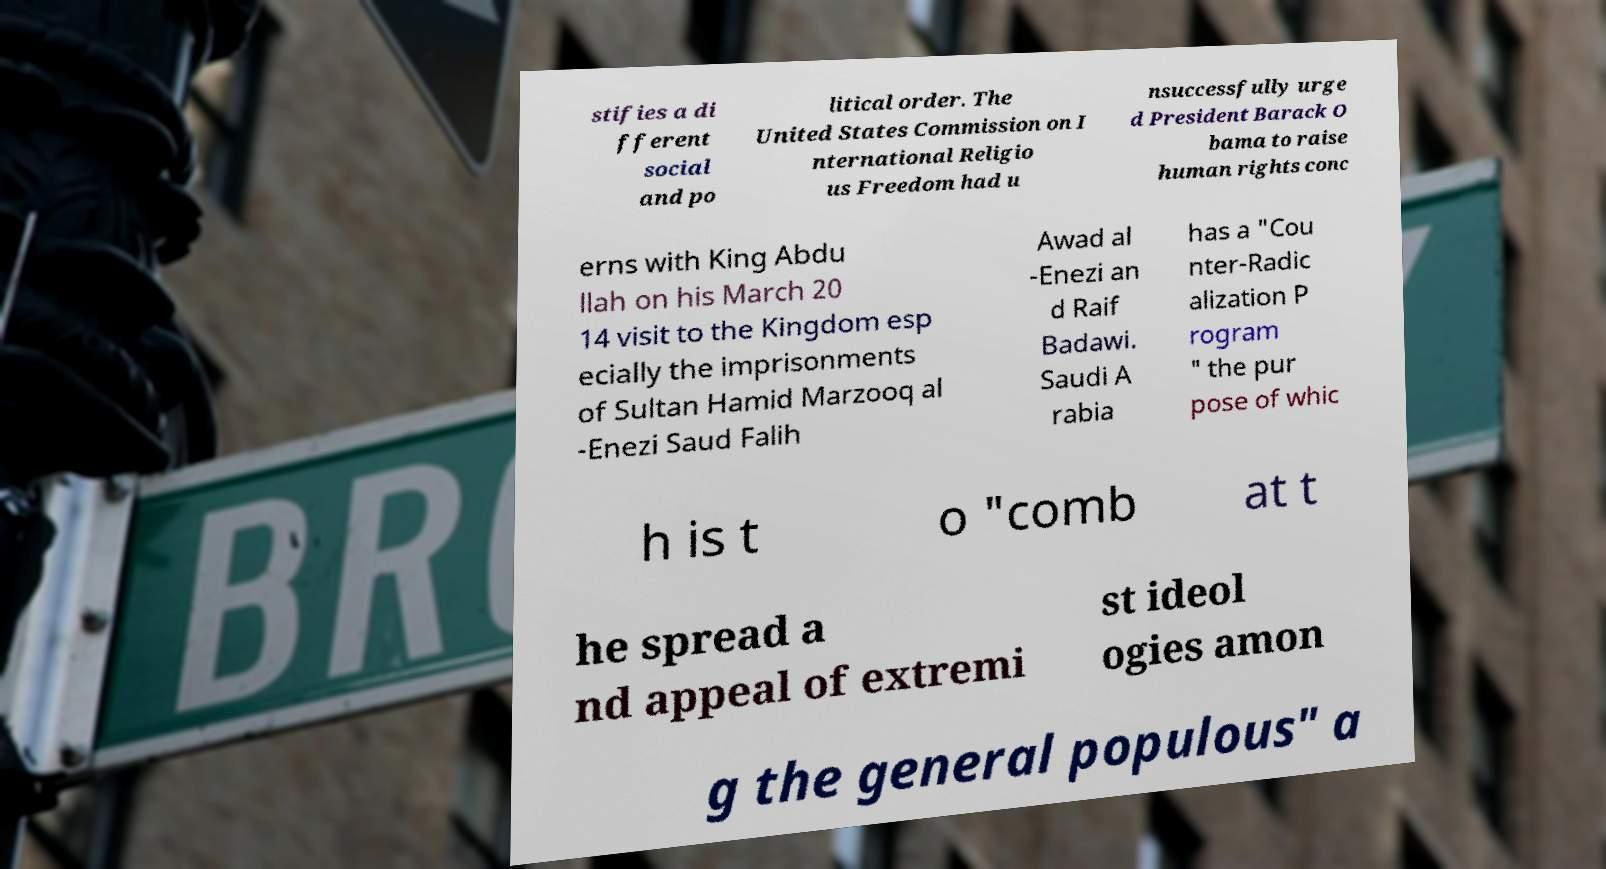For documentation purposes, I need the text within this image transcribed. Could you provide that? stifies a di fferent social and po litical order. The United States Commission on I nternational Religio us Freedom had u nsuccessfully urge d President Barack O bama to raise human rights conc erns with King Abdu llah on his March 20 14 visit to the Kingdom esp ecially the imprisonments of Sultan Hamid Marzooq al -Enezi Saud Falih Awad al -Enezi an d Raif Badawi. Saudi A rabia has a "Cou nter-Radic alization P rogram " the pur pose of whic h is t o "comb at t he spread a nd appeal of extremi st ideol ogies amon g the general populous" a 